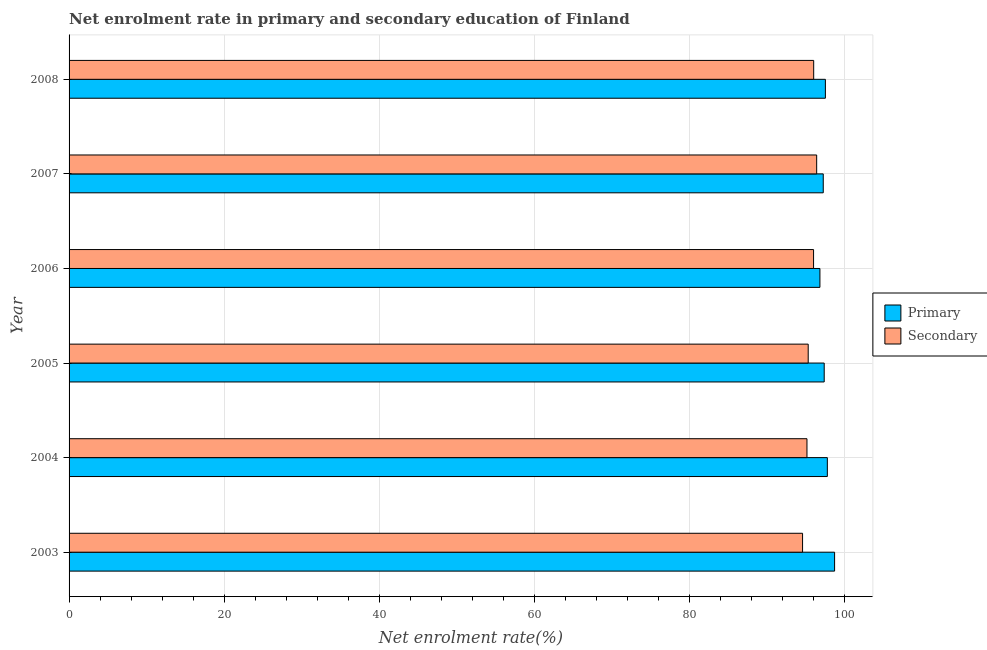Are the number of bars on each tick of the Y-axis equal?
Offer a terse response. Yes. In how many cases, is the number of bars for a given year not equal to the number of legend labels?
Your answer should be very brief. 0. What is the enrollment rate in secondary education in 2005?
Offer a very short reply. 95.27. Across all years, what is the maximum enrollment rate in secondary education?
Offer a terse response. 96.36. Across all years, what is the minimum enrollment rate in secondary education?
Make the answer very short. 94.54. In which year was the enrollment rate in secondary education maximum?
Make the answer very short. 2007. What is the total enrollment rate in secondary education in the graph?
Give a very brief answer. 573.21. What is the difference between the enrollment rate in secondary education in 2003 and that in 2006?
Offer a terse response. -1.42. What is the difference between the enrollment rate in secondary education in 2008 and the enrollment rate in primary education in 2007?
Provide a succinct answer. -1.23. What is the average enrollment rate in primary education per year?
Offer a very short reply. 97.53. In the year 2005, what is the difference between the enrollment rate in primary education and enrollment rate in secondary education?
Make the answer very short. 2.06. In how many years, is the enrollment rate in secondary education greater than 32 %?
Give a very brief answer. 6. What is the ratio of the enrollment rate in secondary education in 2006 to that in 2008?
Give a very brief answer. 1. What is the difference between the highest and the second highest enrollment rate in secondary education?
Keep it short and to the point. 0.38. What is the difference between the highest and the lowest enrollment rate in primary education?
Keep it short and to the point. 1.89. In how many years, is the enrollment rate in primary education greater than the average enrollment rate in primary education taken over all years?
Your answer should be compact. 2. What does the 1st bar from the top in 2006 represents?
Ensure brevity in your answer.  Secondary. What does the 2nd bar from the bottom in 2005 represents?
Offer a terse response. Secondary. How many bars are there?
Make the answer very short. 12. How many years are there in the graph?
Offer a terse response. 6. What is the difference between two consecutive major ticks on the X-axis?
Your answer should be compact. 20. Where does the legend appear in the graph?
Your answer should be compact. Center right. How are the legend labels stacked?
Offer a terse response. Vertical. What is the title of the graph?
Give a very brief answer. Net enrolment rate in primary and secondary education of Finland. Does "From World Bank" appear as one of the legend labels in the graph?
Offer a very short reply. No. What is the label or title of the X-axis?
Your response must be concise. Net enrolment rate(%). What is the Net enrolment rate(%) of Primary in 2003?
Provide a short and direct response. 98.67. What is the Net enrolment rate(%) in Secondary in 2003?
Your answer should be compact. 94.54. What is the Net enrolment rate(%) of Primary in 2004?
Offer a terse response. 97.73. What is the Net enrolment rate(%) in Secondary in 2004?
Keep it short and to the point. 95.11. What is the Net enrolment rate(%) in Primary in 2005?
Your answer should be very brief. 97.33. What is the Net enrolment rate(%) of Secondary in 2005?
Your answer should be very brief. 95.27. What is the Net enrolment rate(%) in Primary in 2006?
Your answer should be very brief. 96.78. What is the Net enrolment rate(%) in Secondary in 2006?
Keep it short and to the point. 95.96. What is the Net enrolment rate(%) of Primary in 2007?
Your answer should be very brief. 97.21. What is the Net enrolment rate(%) of Secondary in 2007?
Offer a very short reply. 96.36. What is the Net enrolment rate(%) in Primary in 2008?
Provide a short and direct response. 97.48. What is the Net enrolment rate(%) of Secondary in 2008?
Provide a short and direct response. 95.97. Across all years, what is the maximum Net enrolment rate(%) in Primary?
Offer a very short reply. 98.67. Across all years, what is the maximum Net enrolment rate(%) in Secondary?
Offer a terse response. 96.36. Across all years, what is the minimum Net enrolment rate(%) of Primary?
Make the answer very short. 96.78. Across all years, what is the minimum Net enrolment rate(%) of Secondary?
Provide a short and direct response. 94.54. What is the total Net enrolment rate(%) in Primary in the graph?
Your answer should be compact. 585.2. What is the total Net enrolment rate(%) of Secondary in the graph?
Your response must be concise. 573.21. What is the difference between the Net enrolment rate(%) in Primary in 2003 and that in 2004?
Your answer should be compact. 0.93. What is the difference between the Net enrolment rate(%) of Secondary in 2003 and that in 2004?
Keep it short and to the point. -0.57. What is the difference between the Net enrolment rate(%) in Primary in 2003 and that in 2005?
Ensure brevity in your answer.  1.34. What is the difference between the Net enrolment rate(%) of Secondary in 2003 and that in 2005?
Ensure brevity in your answer.  -0.73. What is the difference between the Net enrolment rate(%) of Primary in 2003 and that in 2006?
Provide a succinct answer. 1.89. What is the difference between the Net enrolment rate(%) of Secondary in 2003 and that in 2006?
Your answer should be very brief. -1.42. What is the difference between the Net enrolment rate(%) in Primary in 2003 and that in 2007?
Make the answer very short. 1.46. What is the difference between the Net enrolment rate(%) of Secondary in 2003 and that in 2007?
Offer a terse response. -1.82. What is the difference between the Net enrolment rate(%) of Primary in 2003 and that in 2008?
Provide a succinct answer. 1.19. What is the difference between the Net enrolment rate(%) in Secondary in 2003 and that in 2008?
Provide a succinct answer. -1.43. What is the difference between the Net enrolment rate(%) in Primary in 2004 and that in 2005?
Provide a succinct answer. 0.4. What is the difference between the Net enrolment rate(%) of Secondary in 2004 and that in 2005?
Offer a very short reply. -0.16. What is the difference between the Net enrolment rate(%) of Primary in 2004 and that in 2006?
Offer a very short reply. 0.96. What is the difference between the Net enrolment rate(%) of Secondary in 2004 and that in 2006?
Give a very brief answer. -0.85. What is the difference between the Net enrolment rate(%) of Primary in 2004 and that in 2007?
Your response must be concise. 0.53. What is the difference between the Net enrolment rate(%) of Secondary in 2004 and that in 2007?
Offer a very short reply. -1.25. What is the difference between the Net enrolment rate(%) of Primary in 2004 and that in 2008?
Give a very brief answer. 0.25. What is the difference between the Net enrolment rate(%) of Secondary in 2004 and that in 2008?
Provide a short and direct response. -0.87. What is the difference between the Net enrolment rate(%) of Primary in 2005 and that in 2006?
Give a very brief answer. 0.55. What is the difference between the Net enrolment rate(%) in Secondary in 2005 and that in 2006?
Your answer should be compact. -0.69. What is the difference between the Net enrolment rate(%) in Primary in 2005 and that in 2007?
Your answer should be compact. 0.12. What is the difference between the Net enrolment rate(%) of Secondary in 2005 and that in 2007?
Give a very brief answer. -1.09. What is the difference between the Net enrolment rate(%) of Primary in 2005 and that in 2008?
Provide a succinct answer. -0.15. What is the difference between the Net enrolment rate(%) in Secondary in 2005 and that in 2008?
Ensure brevity in your answer.  -0.71. What is the difference between the Net enrolment rate(%) in Primary in 2006 and that in 2007?
Your answer should be very brief. -0.43. What is the difference between the Net enrolment rate(%) of Secondary in 2006 and that in 2007?
Give a very brief answer. -0.4. What is the difference between the Net enrolment rate(%) in Primary in 2006 and that in 2008?
Give a very brief answer. -0.7. What is the difference between the Net enrolment rate(%) of Secondary in 2006 and that in 2008?
Make the answer very short. -0.02. What is the difference between the Net enrolment rate(%) of Primary in 2007 and that in 2008?
Offer a very short reply. -0.28. What is the difference between the Net enrolment rate(%) in Secondary in 2007 and that in 2008?
Make the answer very short. 0.38. What is the difference between the Net enrolment rate(%) in Primary in 2003 and the Net enrolment rate(%) in Secondary in 2004?
Ensure brevity in your answer.  3.56. What is the difference between the Net enrolment rate(%) in Primary in 2003 and the Net enrolment rate(%) in Secondary in 2005?
Offer a very short reply. 3.4. What is the difference between the Net enrolment rate(%) in Primary in 2003 and the Net enrolment rate(%) in Secondary in 2006?
Give a very brief answer. 2.71. What is the difference between the Net enrolment rate(%) in Primary in 2003 and the Net enrolment rate(%) in Secondary in 2007?
Give a very brief answer. 2.31. What is the difference between the Net enrolment rate(%) of Primary in 2003 and the Net enrolment rate(%) of Secondary in 2008?
Offer a very short reply. 2.69. What is the difference between the Net enrolment rate(%) in Primary in 2004 and the Net enrolment rate(%) in Secondary in 2005?
Keep it short and to the point. 2.47. What is the difference between the Net enrolment rate(%) in Primary in 2004 and the Net enrolment rate(%) in Secondary in 2006?
Give a very brief answer. 1.78. What is the difference between the Net enrolment rate(%) of Primary in 2004 and the Net enrolment rate(%) of Secondary in 2007?
Offer a very short reply. 1.38. What is the difference between the Net enrolment rate(%) in Primary in 2004 and the Net enrolment rate(%) in Secondary in 2008?
Offer a very short reply. 1.76. What is the difference between the Net enrolment rate(%) of Primary in 2005 and the Net enrolment rate(%) of Secondary in 2006?
Provide a succinct answer. 1.37. What is the difference between the Net enrolment rate(%) of Primary in 2005 and the Net enrolment rate(%) of Secondary in 2007?
Your answer should be compact. 0.97. What is the difference between the Net enrolment rate(%) of Primary in 2005 and the Net enrolment rate(%) of Secondary in 2008?
Your answer should be very brief. 1.36. What is the difference between the Net enrolment rate(%) in Primary in 2006 and the Net enrolment rate(%) in Secondary in 2007?
Your answer should be very brief. 0.42. What is the difference between the Net enrolment rate(%) of Primary in 2006 and the Net enrolment rate(%) of Secondary in 2008?
Provide a short and direct response. 0.8. What is the difference between the Net enrolment rate(%) of Primary in 2007 and the Net enrolment rate(%) of Secondary in 2008?
Offer a very short reply. 1.23. What is the average Net enrolment rate(%) of Primary per year?
Make the answer very short. 97.53. What is the average Net enrolment rate(%) in Secondary per year?
Your answer should be very brief. 95.53. In the year 2003, what is the difference between the Net enrolment rate(%) in Primary and Net enrolment rate(%) in Secondary?
Provide a succinct answer. 4.13. In the year 2004, what is the difference between the Net enrolment rate(%) in Primary and Net enrolment rate(%) in Secondary?
Provide a short and direct response. 2.63. In the year 2005, what is the difference between the Net enrolment rate(%) in Primary and Net enrolment rate(%) in Secondary?
Give a very brief answer. 2.06. In the year 2006, what is the difference between the Net enrolment rate(%) of Primary and Net enrolment rate(%) of Secondary?
Provide a succinct answer. 0.82. In the year 2007, what is the difference between the Net enrolment rate(%) in Primary and Net enrolment rate(%) in Secondary?
Your answer should be very brief. 0.85. In the year 2008, what is the difference between the Net enrolment rate(%) in Primary and Net enrolment rate(%) in Secondary?
Offer a terse response. 1.51. What is the ratio of the Net enrolment rate(%) in Primary in 2003 to that in 2004?
Offer a very short reply. 1.01. What is the ratio of the Net enrolment rate(%) in Secondary in 2003 to that in 2004?
Ensure brevity in your answer.  0.99. What is the ratio of the Net enrolment rate(%) of Primary in 2003 to that in 2005?
Your answer should be compact. 1.01. What is the ratio of the Net enrolment rate(%) of Secondary in 2003 to that in 2005?
Your answer should be very brief. 0.99. What is the ratio of the Net enrolment rate(%) of Primary in 2003 to that in 2006?
Offer a very short reply. 1.02. What is the ratio of the Net enrolment rate(%) in Secondary in 2003 to that in 2006?
Provide a short and direct response. 0.99. What is the ratio of the Net enrolment rate(%) in Secondary in 2003 to that in 2007?
Provide a succinct answer. 0.98. What is the ratio of the Net enrolment rate(%) of Primary in 2003 to that in 2008?
Provide a succinct answer. 1.01. What is the ratio of the Net enrolment rate(%) of Secondary in 2004 to that in 2005?
Your answer should be very brief. 1. What is the ratio of the Net enrolment rate(%) of Primary in 2004 to that in 2006?
Give a very brief answer. 1.01. What is the ratio of the Net enrolment rate(%) in Secondary in 2004 to that in 2006?
Ensure brevity in your answer.  0.99. What is the ratio of the Net enrolment rate(%) of Primary in 2004 to that in 2007?
Provide a short and direct response. 1.01. What is the ratio of the Net enrolment rate(%) in Secondary in 2004 to that in 2007?
Offer a terse response. 0.99. What is the ratio of the Net enrolment rate(%) in Primary in 2004 to that in 2008?
Make the answer very short. 1. What is the ratio of the Net enrolment rate(%) of Secondary in 2004 to that in 2008?
Offer a very short reply. 0.99. What is the ratio of the Net enrolment rate(%) of Primary in 2005 to that in 2007?
Offer a terse response. 1. What is the ratio of the Net enrolment rate(%) in Secondary in 2005 to that in 2007?
Provide a succinct answer. 0.99. What is the ratio of the Net enrolment rate(%) in Primary in 2006 to that in 2007?
Ensure brevity in your answer.  1. What is the ratio of the Net enrolment rate(%) in Secondary in 2006 to that in 2008?
Keep it short and to the point. 1. What is the ratio of the Net enrolment rate(%) of Primary in 2007 to that in 2008?
Your response must be concise. 1. What is the ratio of the Net enrolment rate(%) of Secondary in 2007 to that in 2008?
Your response must be concise. 1. What is the difference between the highest and the second highest Net enrolment rate(%) of Primary?
Your response must be concise. 0.93. What is the difference between the highest and the second highest Net enrolment rate(%) in Secondary?
Provide a succinct answer. 0.38. What is the difference between the highest and the lowest Net enrolment rate(%) of Primary?
Keep it short and to the point. 1.89. What is the difference between the highest and the lowest Net enrolment rate(%) in Secondary?
Your answer should be compact. 1.82. 